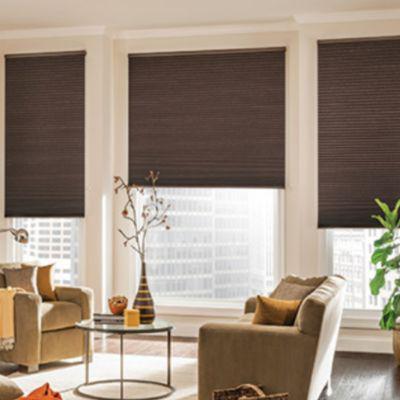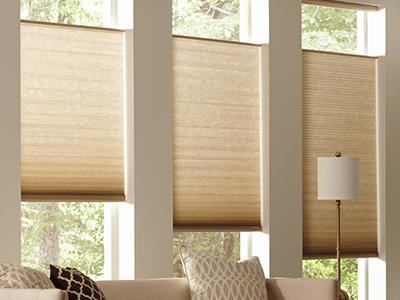The first image is the image on the left, the second image is the image on the right. For the images displayed, is the sentence "All of the window blinds are only partially open." factually correct? Answer yes or no. Yes. The first image is the image on the left, the second image is the image on the right. Analyze the images presented: Is the assertion "The left and right image contains the same number of blinds." valid? Answer yes or no. Yes. 